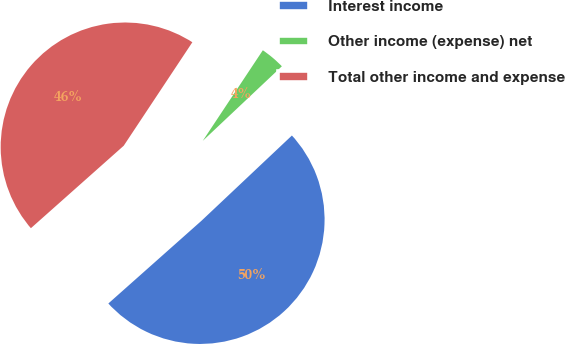Convert chart. <chart><loc_0><loc_0><loc_500><loc_500><pie_chart><fcel>Interest income<fcel>Other income (expense) net<fcel>Total other income and expense<nl><fcel>50.47%<fcel>3.65%<fcel>45.88%<nl></chart> 